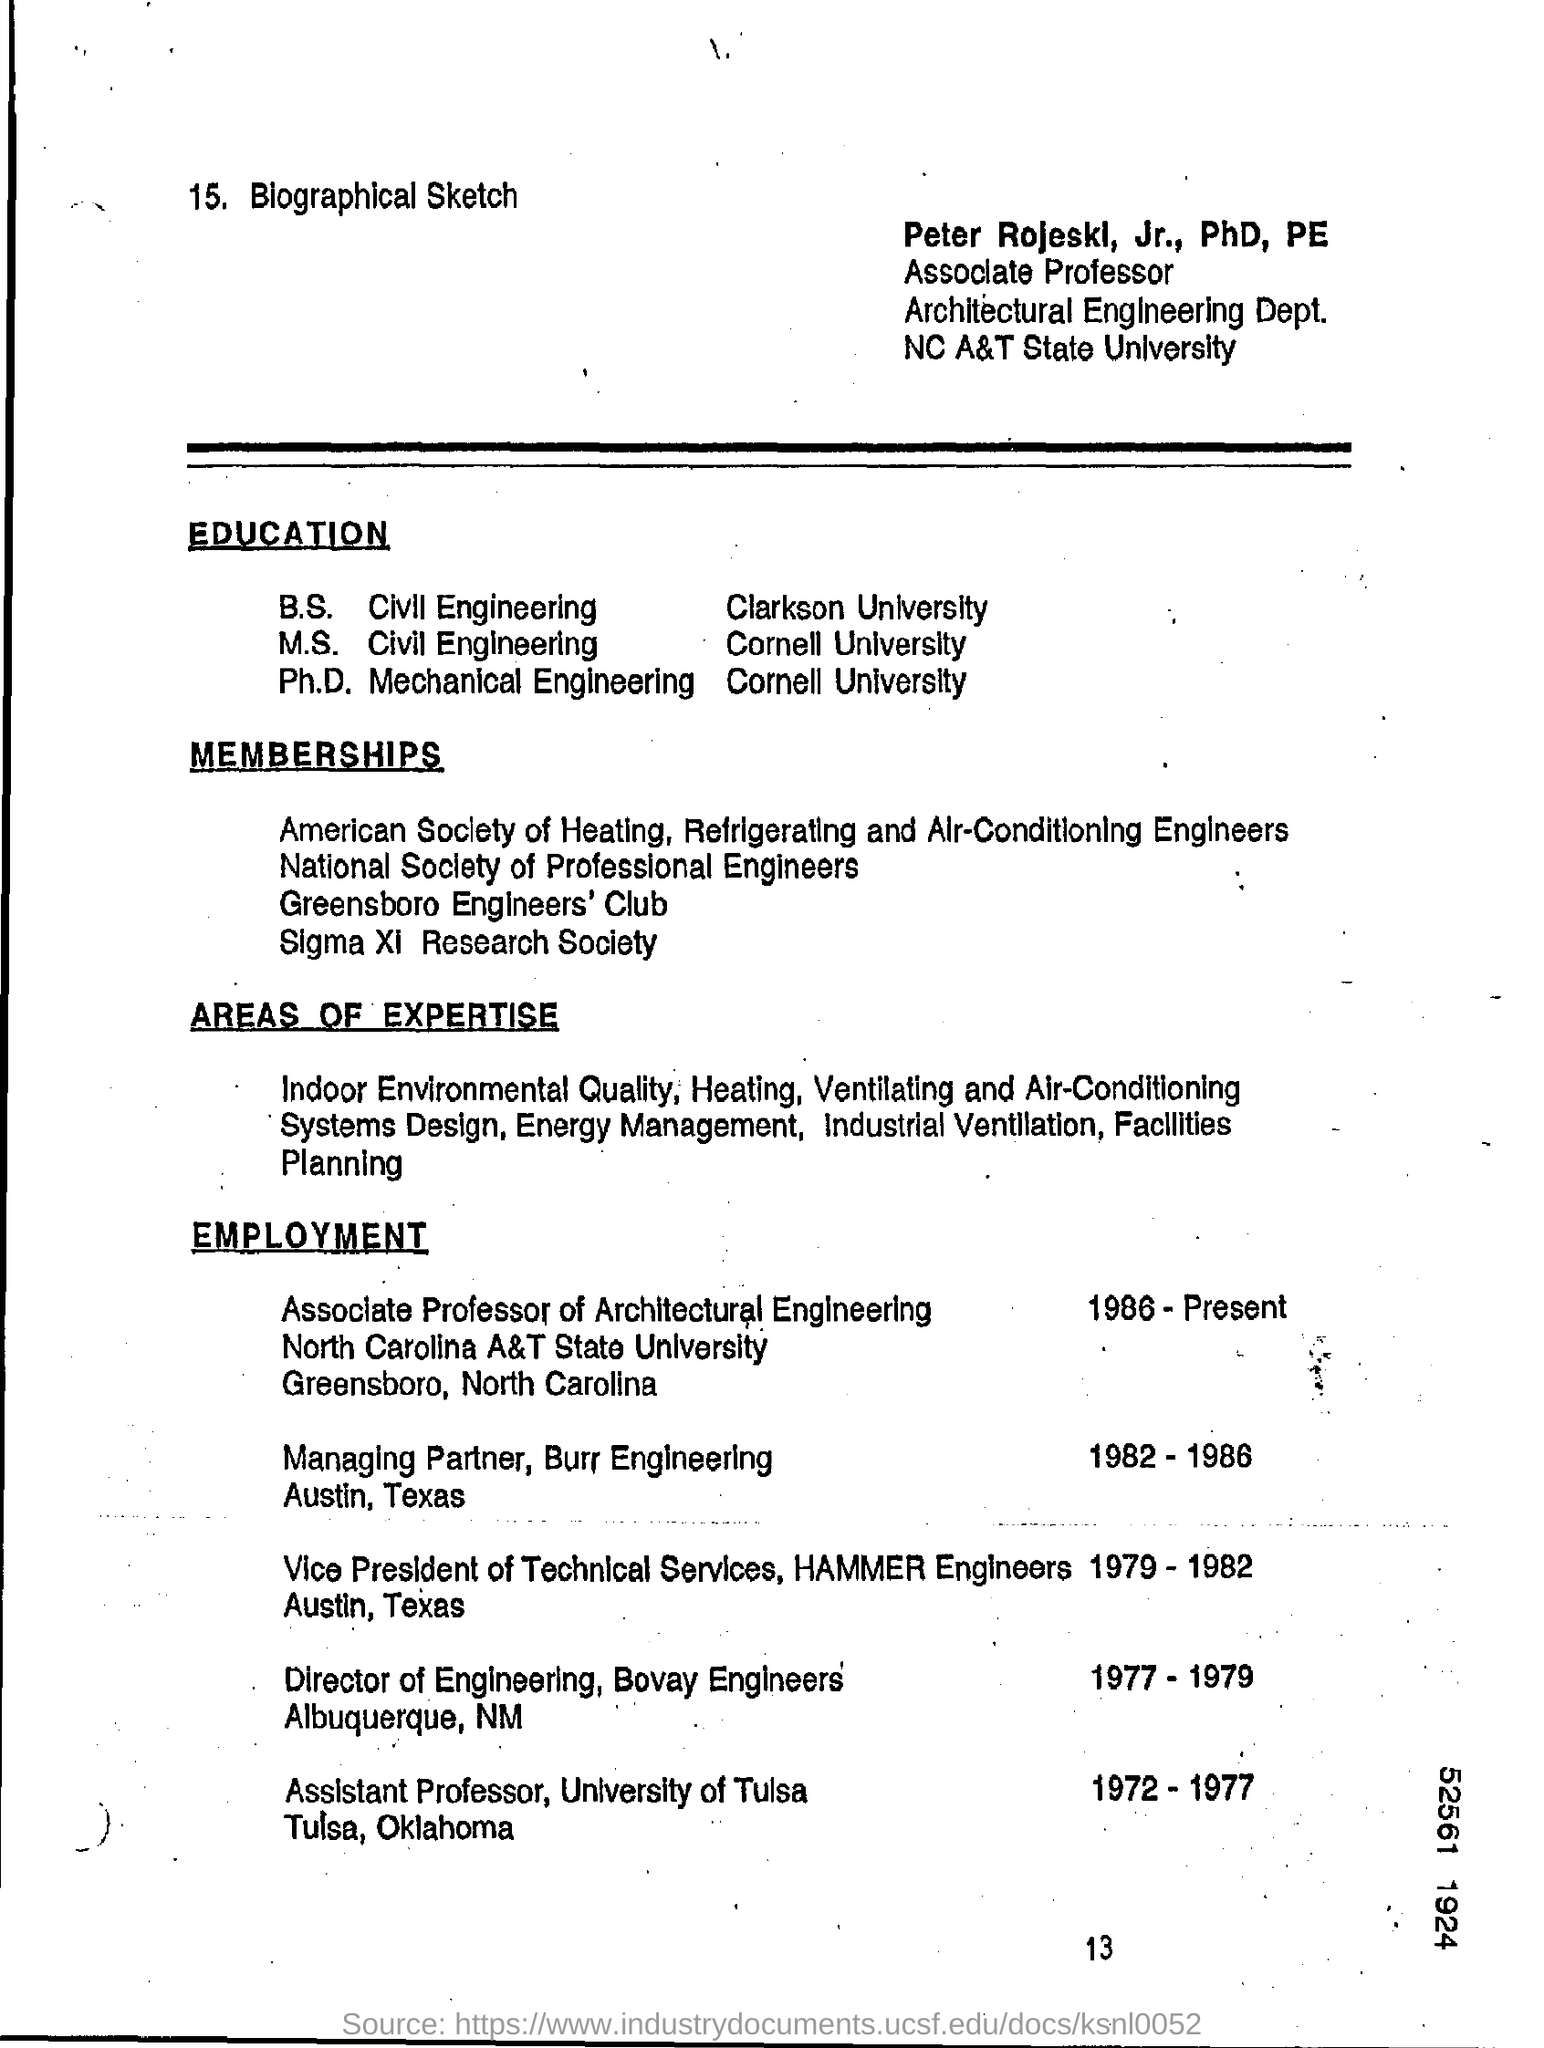List a handful of essential elements in this visual. Peter Rojeskl, Jr., PhD, PE is an Associate Professor. Peter Rosskopf completed his Ph.D. in from Cornell University. 